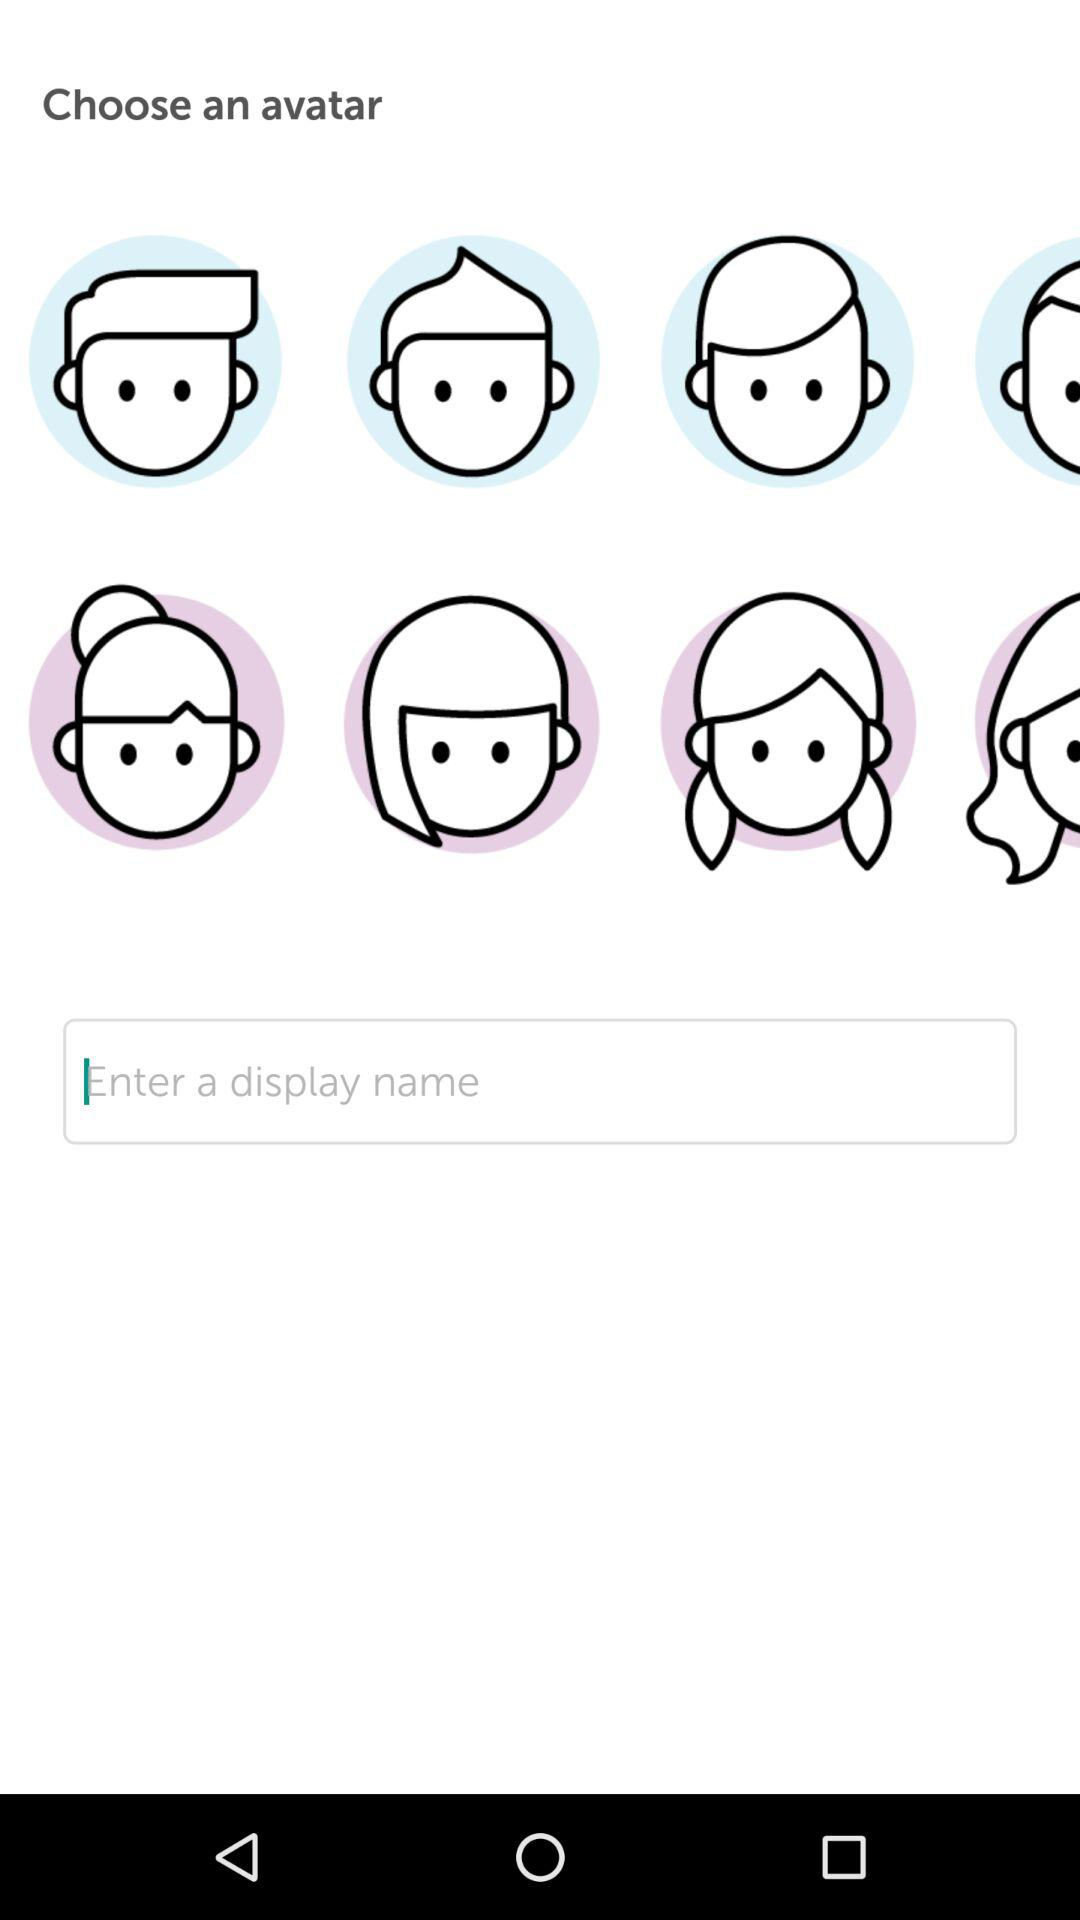How many avatar options are there in total?
Answer the question using a single word or phrase. 8 